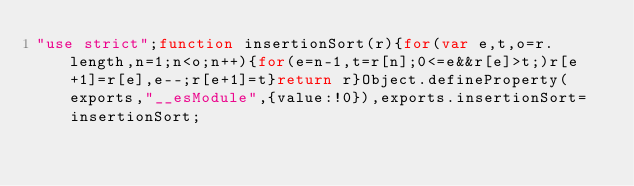<code> <loc_0><loc_0><loc_500><loc_500><_JavaScript_>"use strict";function insertionSort(r){for(var e,t,o=r.length,n=1;n<o;n++){for(e=n-1,t=r[n];0<=e&&r[e]>t;)r[e+1]=r[e],e--;r[e+1]=t}return r}Object.defineProperty(exports,"__esModule",{value:!0}),exports.insertionSort=insertionSort;</code> 